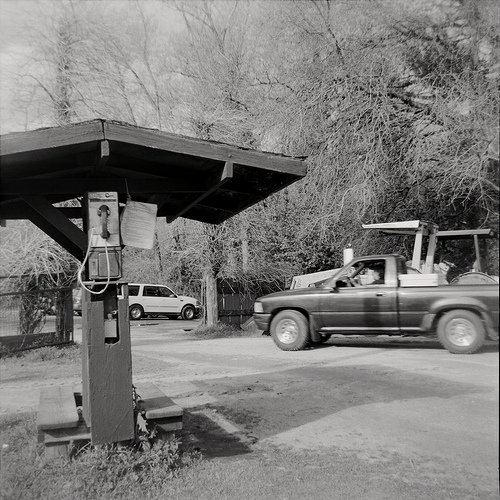Please provide a short description for this region: [0.65, 0.8, 0.67, 0.84]. The region [0.65, 0.8, 0.67, 0.84] depicts the edge of the shade structure, providing some relief from sunlight. 